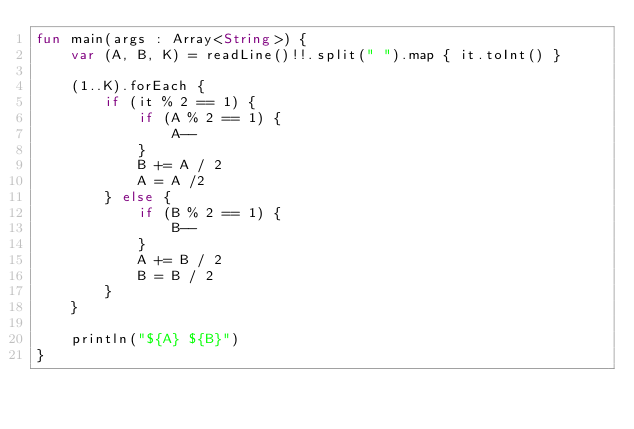<code> <loc_0><loc_0><loc_500><loc_500><_Kotlin_>fun main(args : Array<String>) {
    var (A, B, K) = readLine()!!.split(" ").map { it.toInt() }

    (1..K).forEach {
        if (it % 2 == 1) {
            if (A % 2 == 1) {
                A--
            }
            B += A / 2
            A = A /2
        } else {
            if (B % 2 == 1) {
                B--
            }
            A += B / 2
            B = B / 2
        }
    }

    println("${A} ${B}")
}</code> 